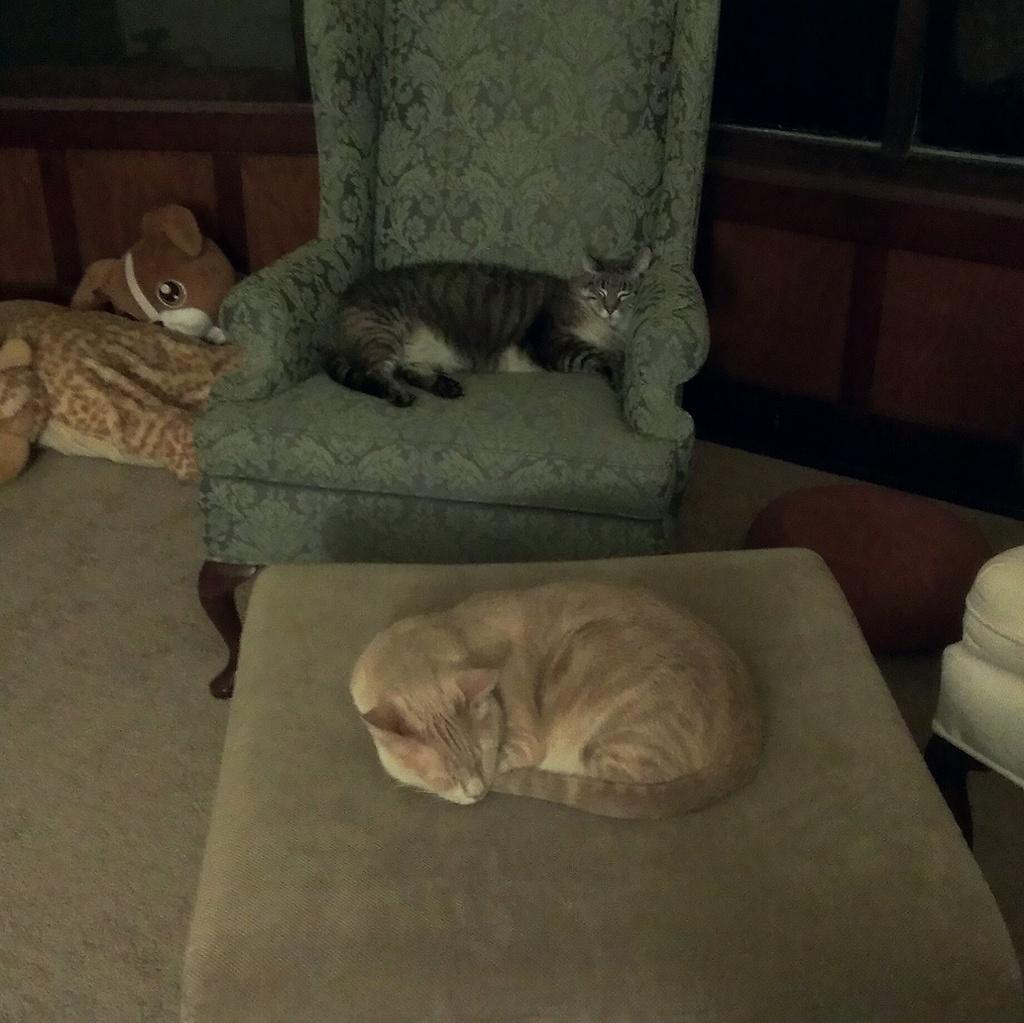Please provide a concise description of this image. In this picture, we can see two cats, we can see some objects on the ground like toys, chairs, we can see the background. 